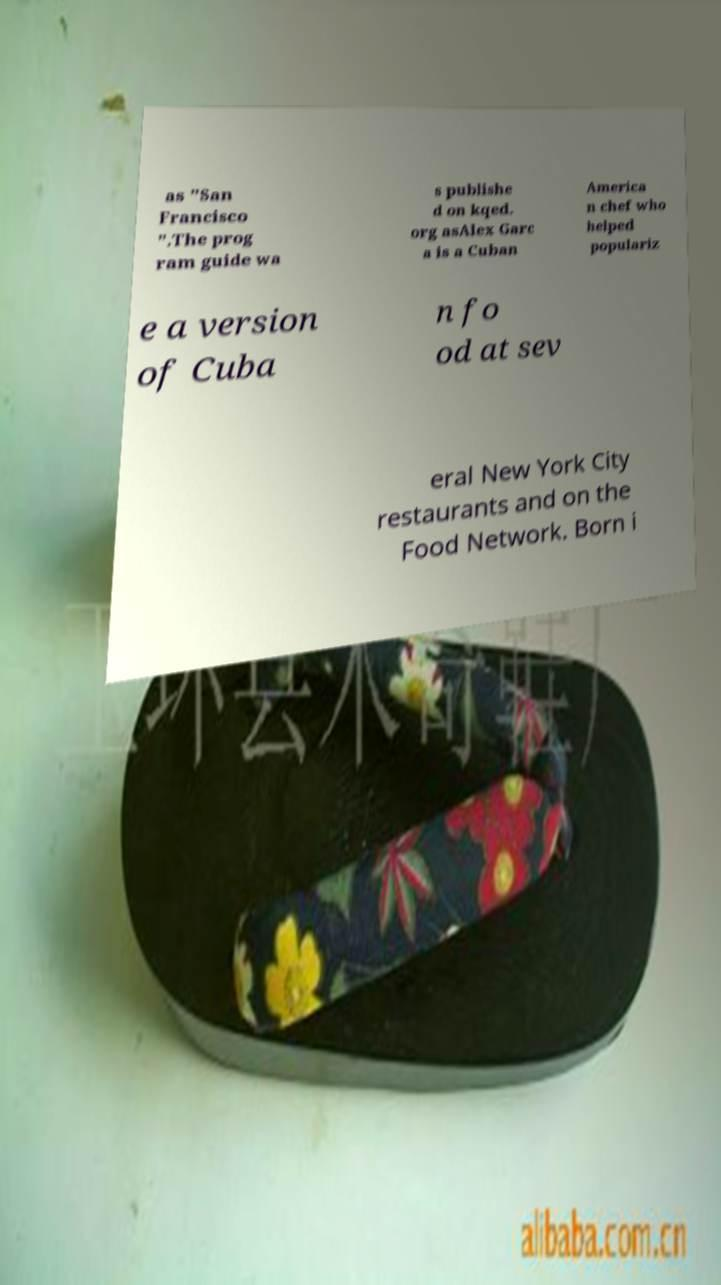There's text embedded in this image that I need extracted. Can you transcribe it verbatim? as "San Francisco ".The prog ram guide wa s publishe d on kqed. org asAlex Garc a is a Cuban America n chef who helped populariz e a version of Cuba n fo od at sev eral New York City restaurants and on the Food Network. Born i 